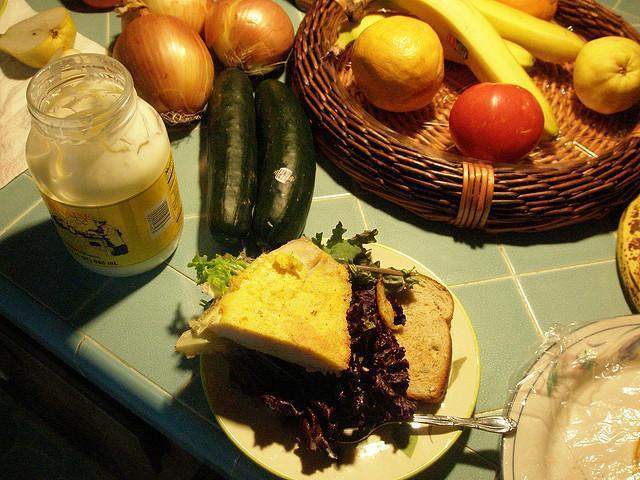Does the description: "The sandwich is in front of the banana." accurately reflect the image?
Answer yes or no. Yes. Evaluate: Does the caption "The sandwich is off the banana." match the image?
Answer yes or no. Yes. Verify the accuracy of this image caption: "The banana is touching the sandwich.".
Answer yes or no. No. 